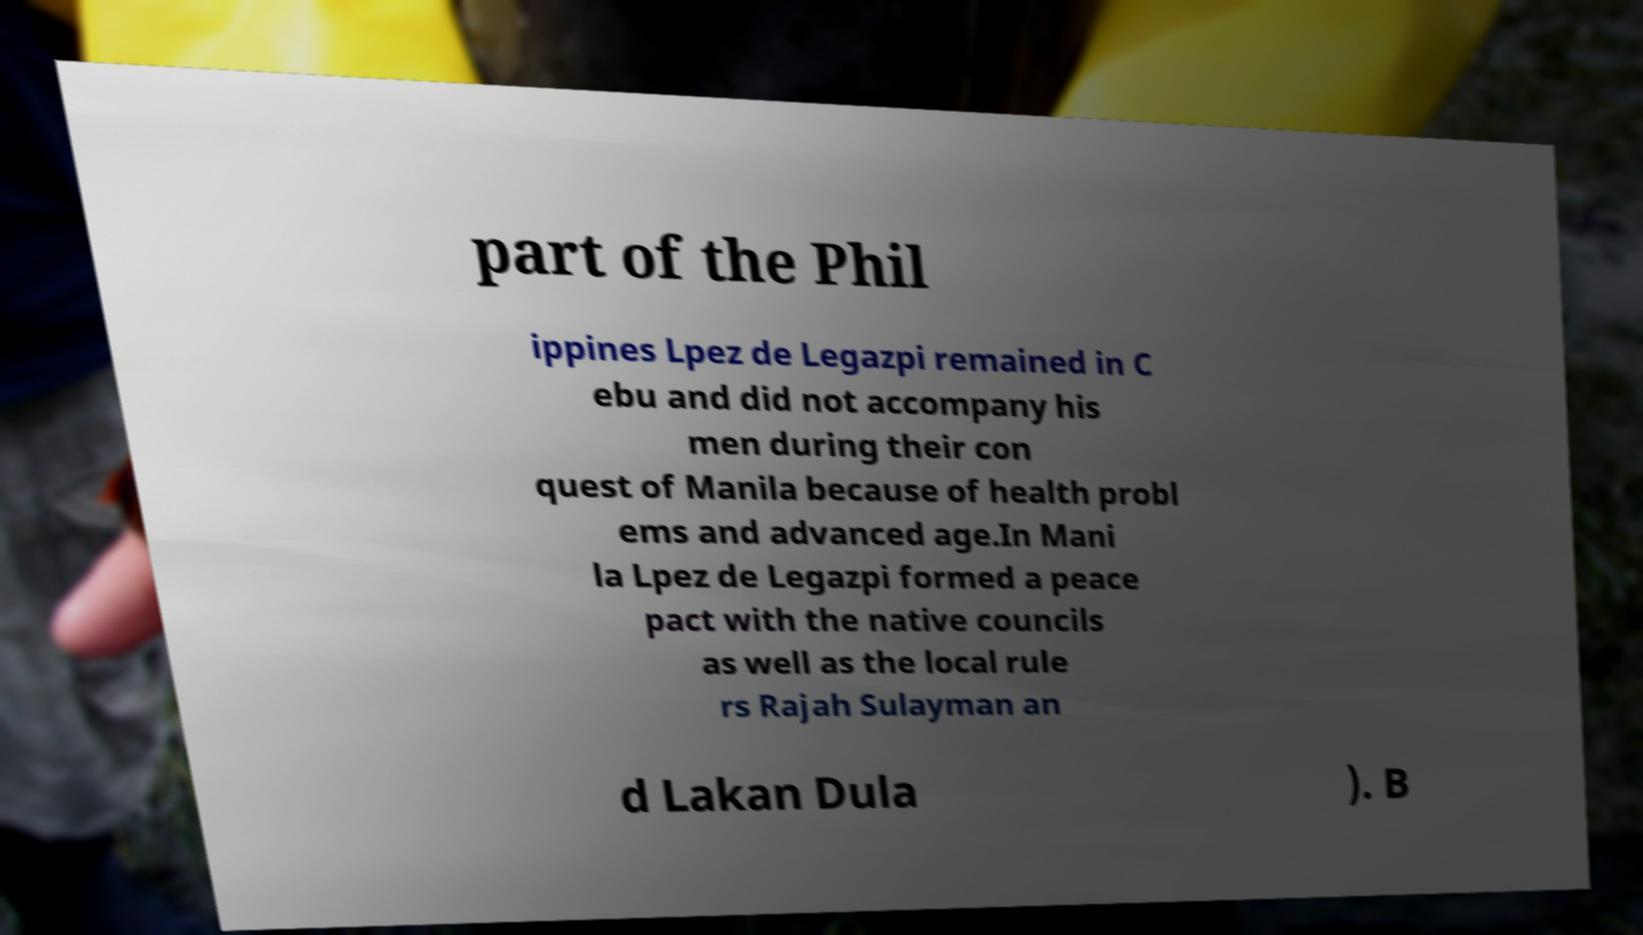There's text embedded in this image that I need extracted. Can you transcribe it verbatim? part of the Phil ippines Lpez de Legazpi remained in C ebu and did not accompany his men during their con quest of Manila because of health probl ems and advanced age.In Mani la Lpez de Legazpi formed a peace pact with the native councils as well as the local rule rs Rajah Sulayman an d Lakan Dula ). B 